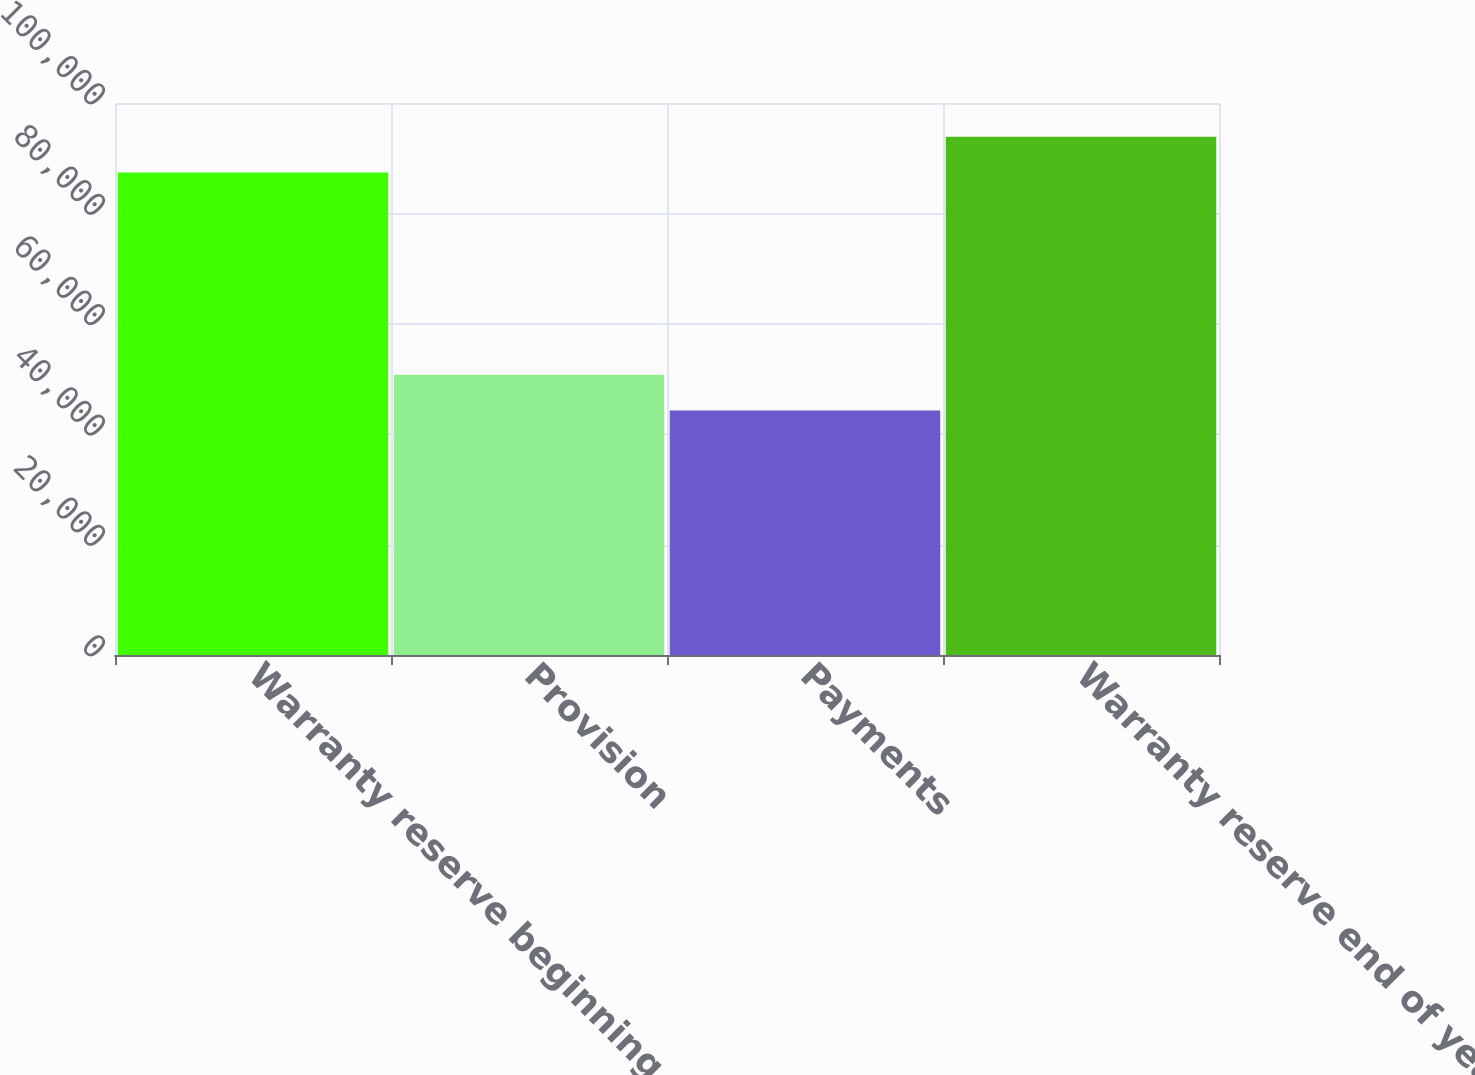<chart> <loc_0><loc_0><loc_500><loc_500><bar_chart><fcel>Warranty reserve beginning of<fcel>Provision<fcel>Payments<fcel>Warranty reserve end of year<nl><fcel>87407<fcel>50787<fcel>44299<fcel>93895<nl></chart> 